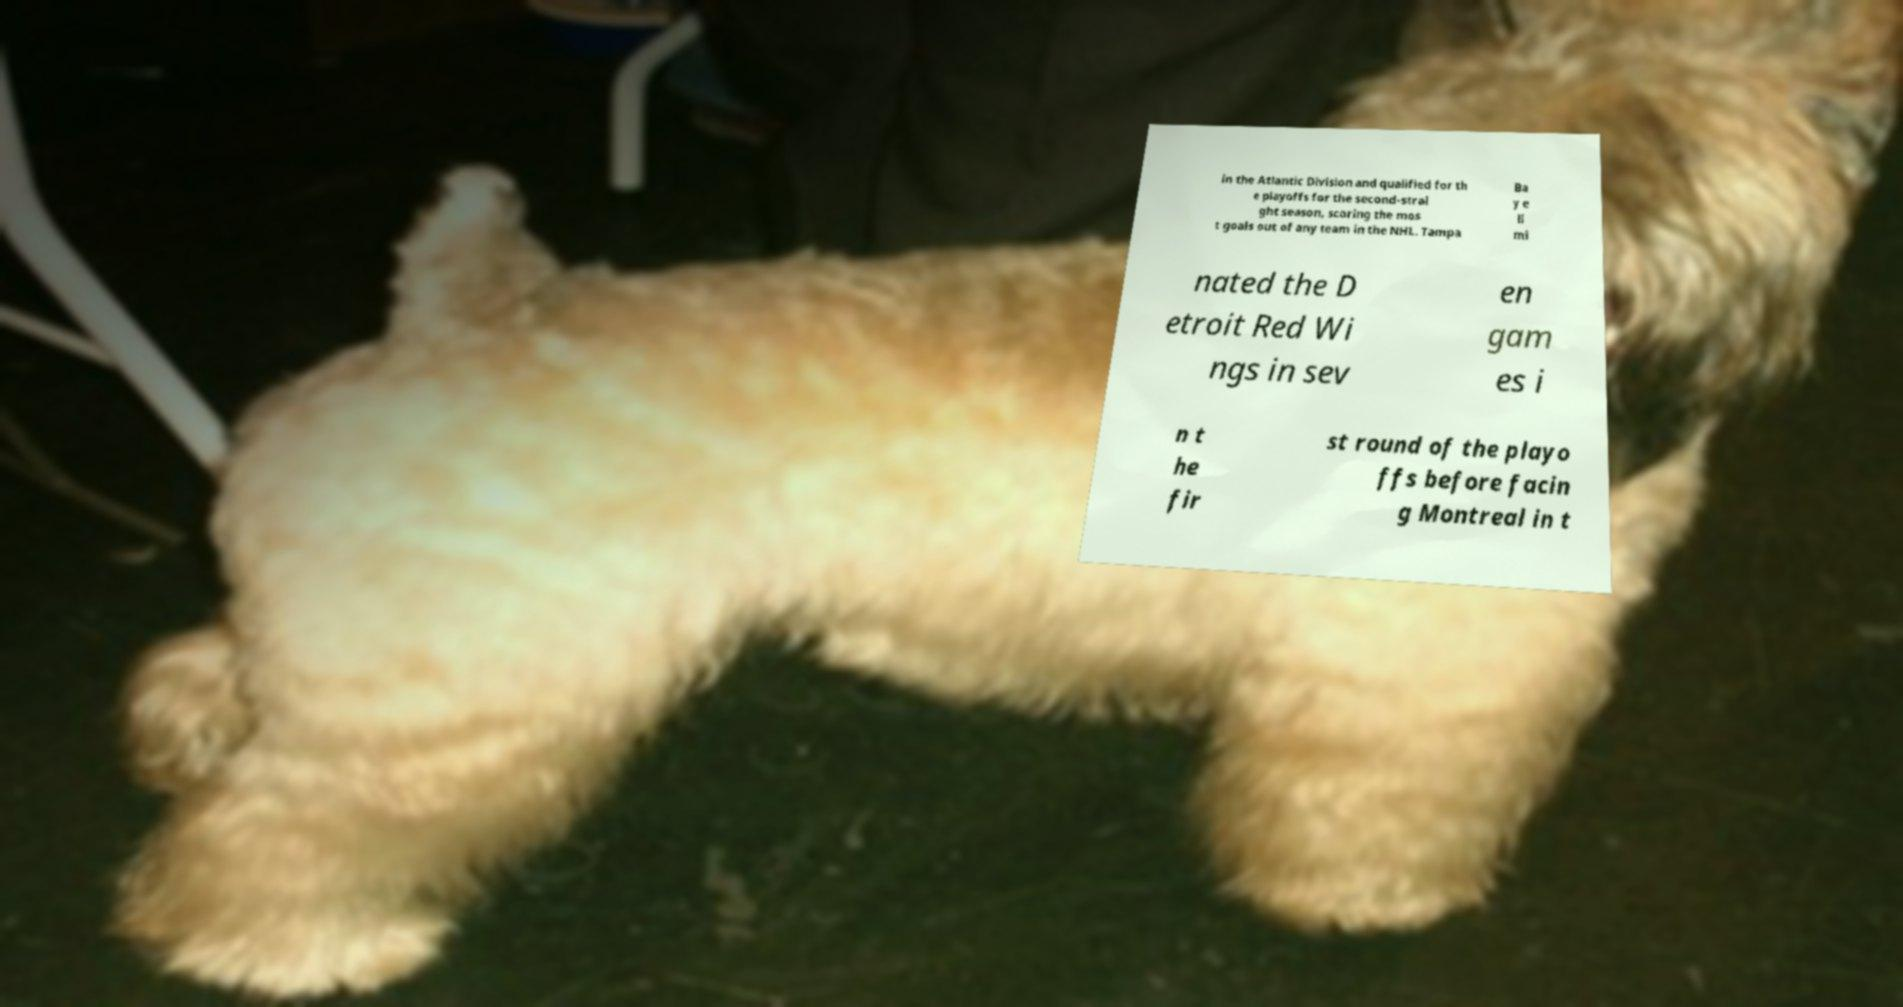For documentation purposes, I need the text within this image transcribed. Could you provide that? in the Atlantic Division and qualified for th e playoffs for the second-strai ght season, scoring the mos t goals out of any team in the NHL. Tampa Ba y e li mi nated the D etroit Red Wi ngs in sev en gam es i n t he fir st round of the playo ffs before facin g Montreal in t 